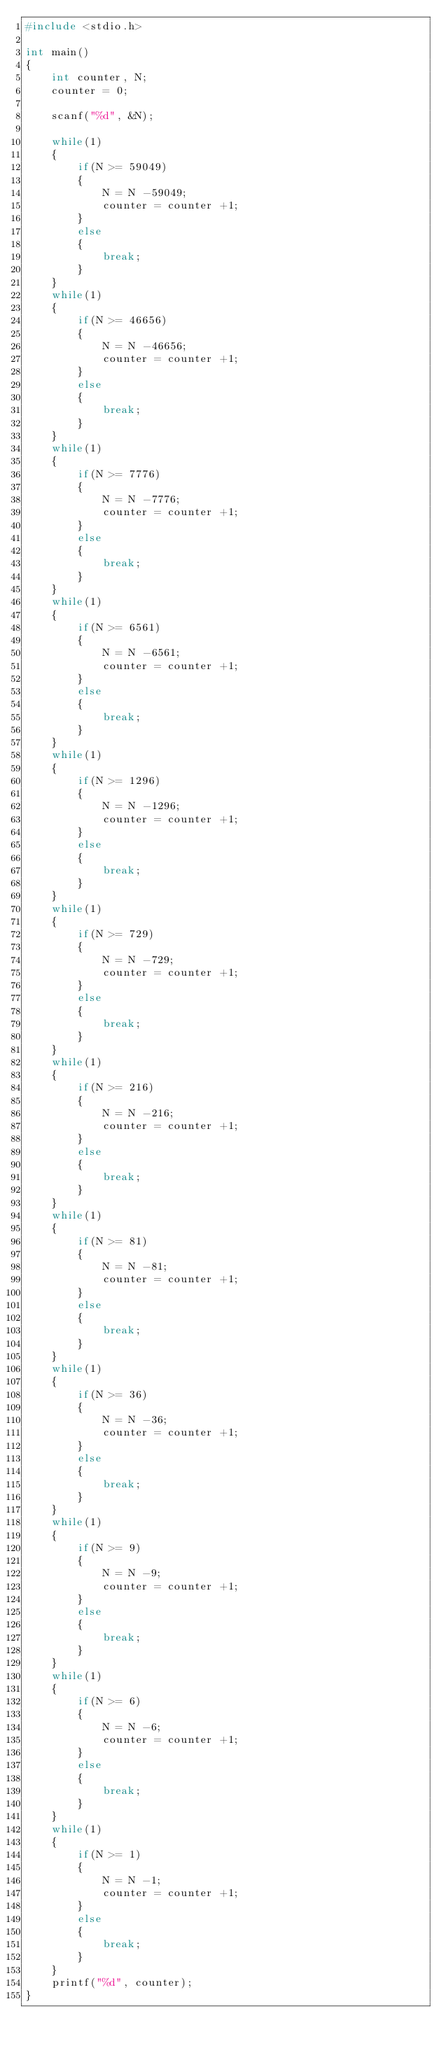Convert code to text. <code><loc_0><loc_0><loc_500><loc_500><_C_>#include <stdio.h>

int main()
{
	int counter, N;
	counter = 0;

	scanf("%d", &N);

	while(1)
	{
		if(N >= 59049)
		{
			N = N -59049;
			counter = counter +1;
		}
		else
		{
			break;
		}
	}
	while(1)
	{
		if(N >= 46656)
		{
			N = N -46656;
			counter = counter +1;
		}
		else
		{
			break;
		}
	}
	while(1)
	{
		if(N >= 7776)
		{
			N = N -7776;
			counter = counter +1;
		}
		else
		{
			break;
		}
	}
	while(1)
	{
		if(N >= 6561)
		{
			N = N -6561;
			counter = counter +1;
		}
		else
		{
			break;
		}
	}
	while(1)
	{
		if(N >= 1296)
		{
			N = N -1296;
			counter = counter +1;
		}
		else
		{
			break;
		}
	}
	while(1)
	{
		if(N >= 729)
		{
			N = N -729;
			counter = counter +1;
		}
		else
		{
			break;
		}
	}
	while(1)
	{
		if(N >= 216)
		{
			N = N -216;
			counter = counter +1;
		}
		else
		{
			break;
		}
	}
	while(1)
	{
		if(N >= 81)
		{
			N = N -81;
			counter = counter +1;
		}
		else
		{
			break;
		}
	}
	while(1)
	{
		if(N >= 36)
		{
			N = N -36;
			counter = counter +1;
		}
		else
		{
			break;
		}
	}
	while(1)
	{
		if(N >= 9)
		{
			N = N -9;
			counter = counter +1;
		}
		else
		{
			break;
		}
	}
	while(1)
	{
		if(N >= 6)
		{
			N = N -6;
			counter = counter +1;
		}
		else
		{
			break;
		}
	}
	while(1)
	{
		if(N >= 1)
		{
			N = N -1;
			counter = counter +1;
		}
		else
		{
			break;
		}
	}
	printf("%d", counter);
}</code> 